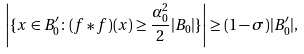Convert formula to latex. <formula><loc_0><loc_0><loc_500><loc_500>\left | \{ x \in B _ { 0 } ^ { \prime } \colon ( f * f ) ( x ) \geq \frac { \alpha _ { 0 } ^ { 2 } } { 2 } | B _ { 0 } | \} \right | \geq ( 1 - \sigma ) | B _ { 0 } ^ { \prime } | ,</formula> 